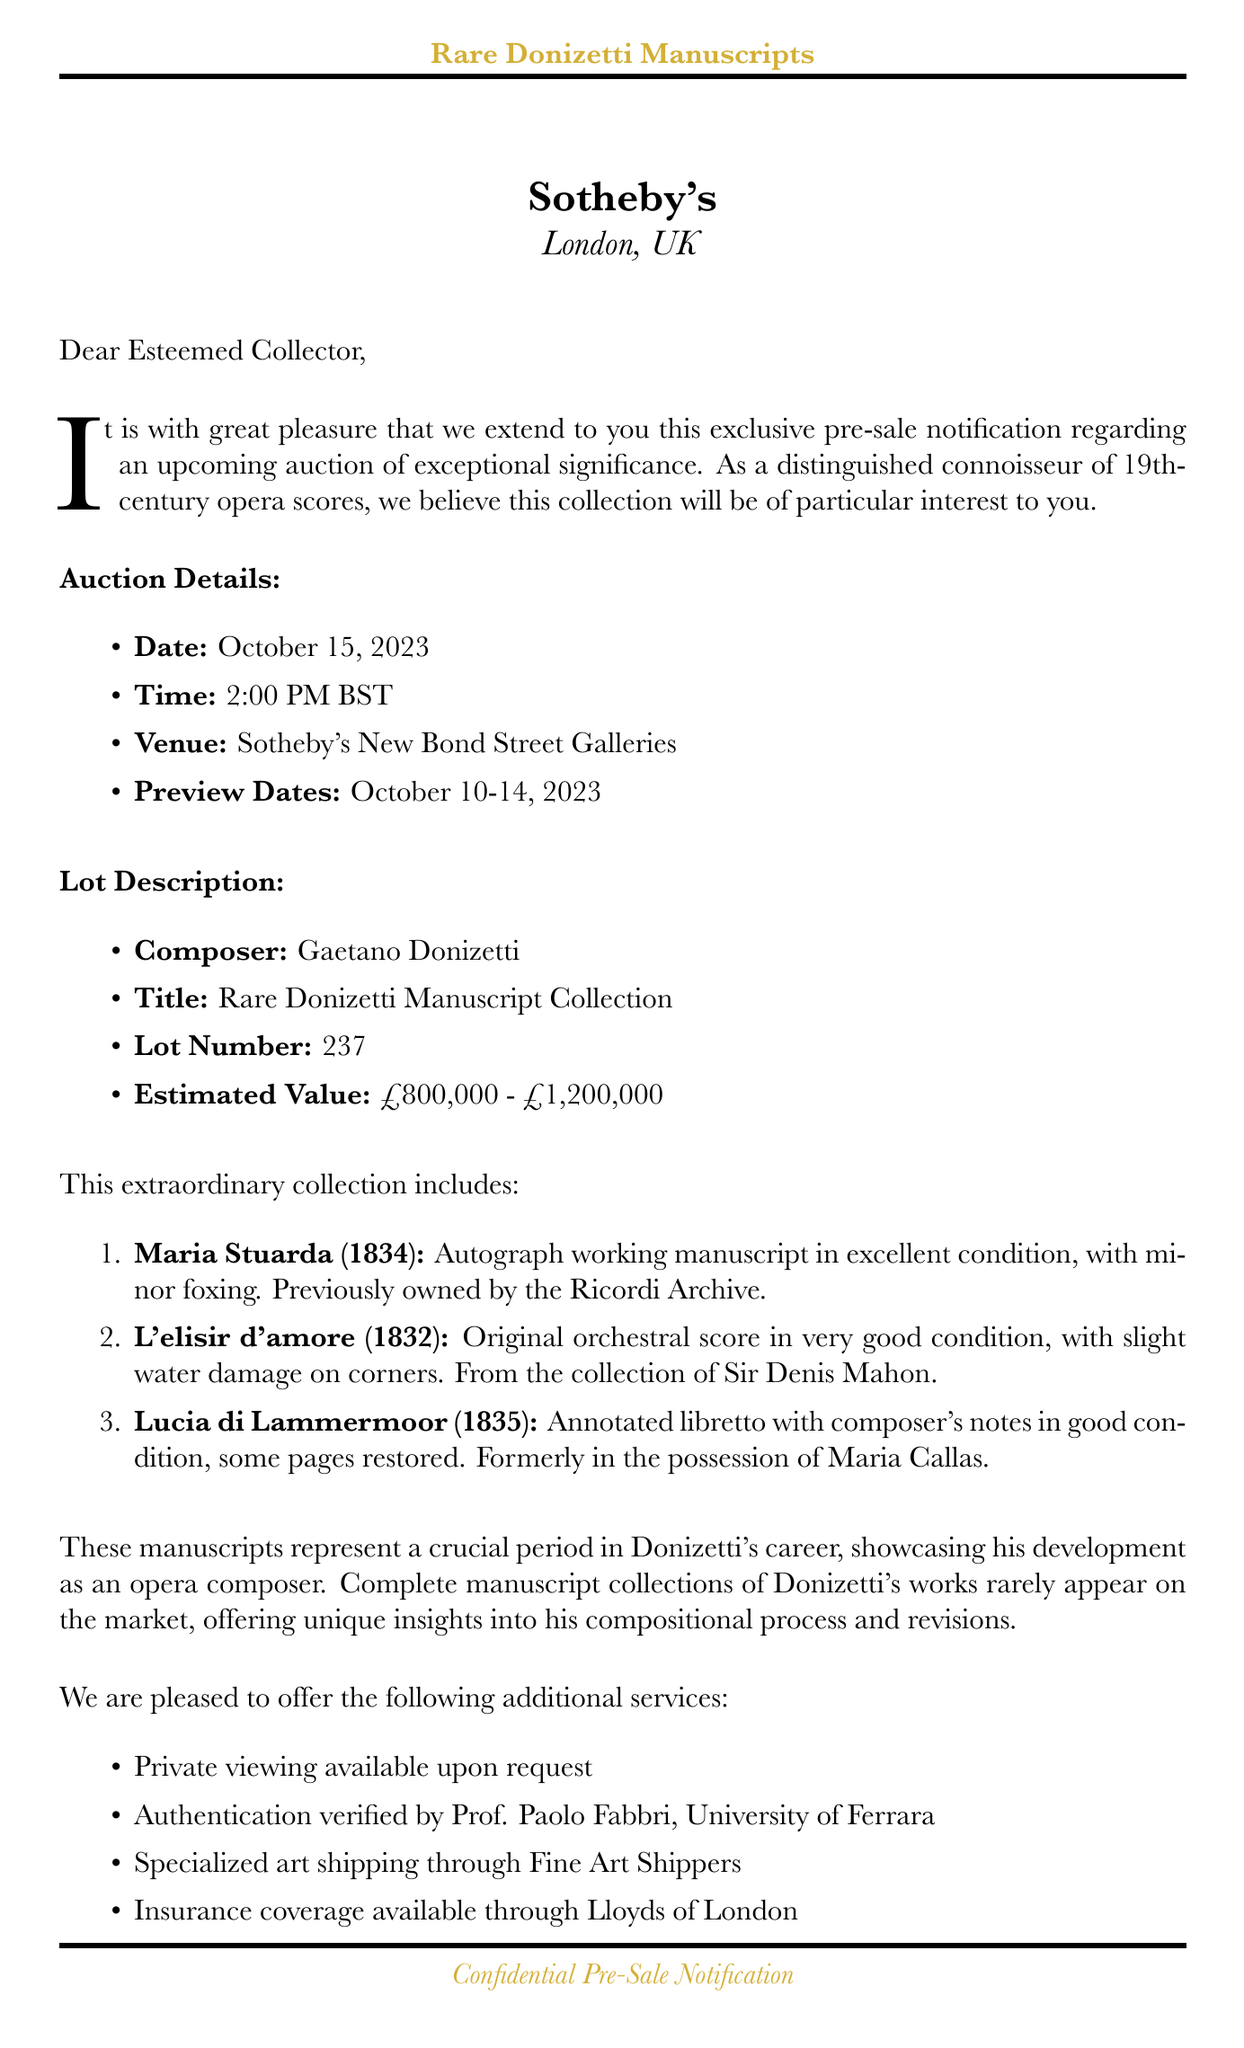What is the auction date? The auction date is explicitly stated in the document as October 15, 2023.
Answer: October 15, 2023 Who is the contact person? The contact person is named in the document, specifically Dr. Elizabeth Hawthorne.
Answer: Dr. Elizabeth Hawthorne What is the estimated value range? The estimated value is specified as ranging from £800,000 to £1,200,000.
Answer: £800,000 - £1,200,000 What condition is the manuscript of "L'elisir d'amore" in? The document provides information about the condition of the manuscripts, stating "very good, slight water damage on corners" for "L'elisir d'amore."
Answer: Very good, slight water damage on corners Why are these manuscripts significant? The significance is explained in the historical context section, indicating they represent a crucial period in Donizetti's career.
Answer: Crucial period in Donizetti's career What provenance is listed for the "Maria Stuarda" manuscript? The provenance is mentioned as previously owned by the Ricordi Archive.
Answer: Previously owned by the Ricordi Archive What additional service is offered for viewing? The document states that private viewing is available upon request.
Answer: Private viewing available upon request Who is providing authentication for the manuscripts? The document specifies that authentication is verified by Prof. Paolo Fabbri from the University of Ferrara.
Answer: Prof. Paolo Fabbri, University of Ferrara 